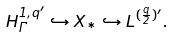<formula> <loc_0><loc_0><loc_500><loc_500>H ^ { 1 , q ^ { \prime } } _ { \Gamma } \hookrightarrow X _ { * } \hookrightarrow L ^ { ( \frac { q } { 2 } ) ^ { \prime } } .</formula> 